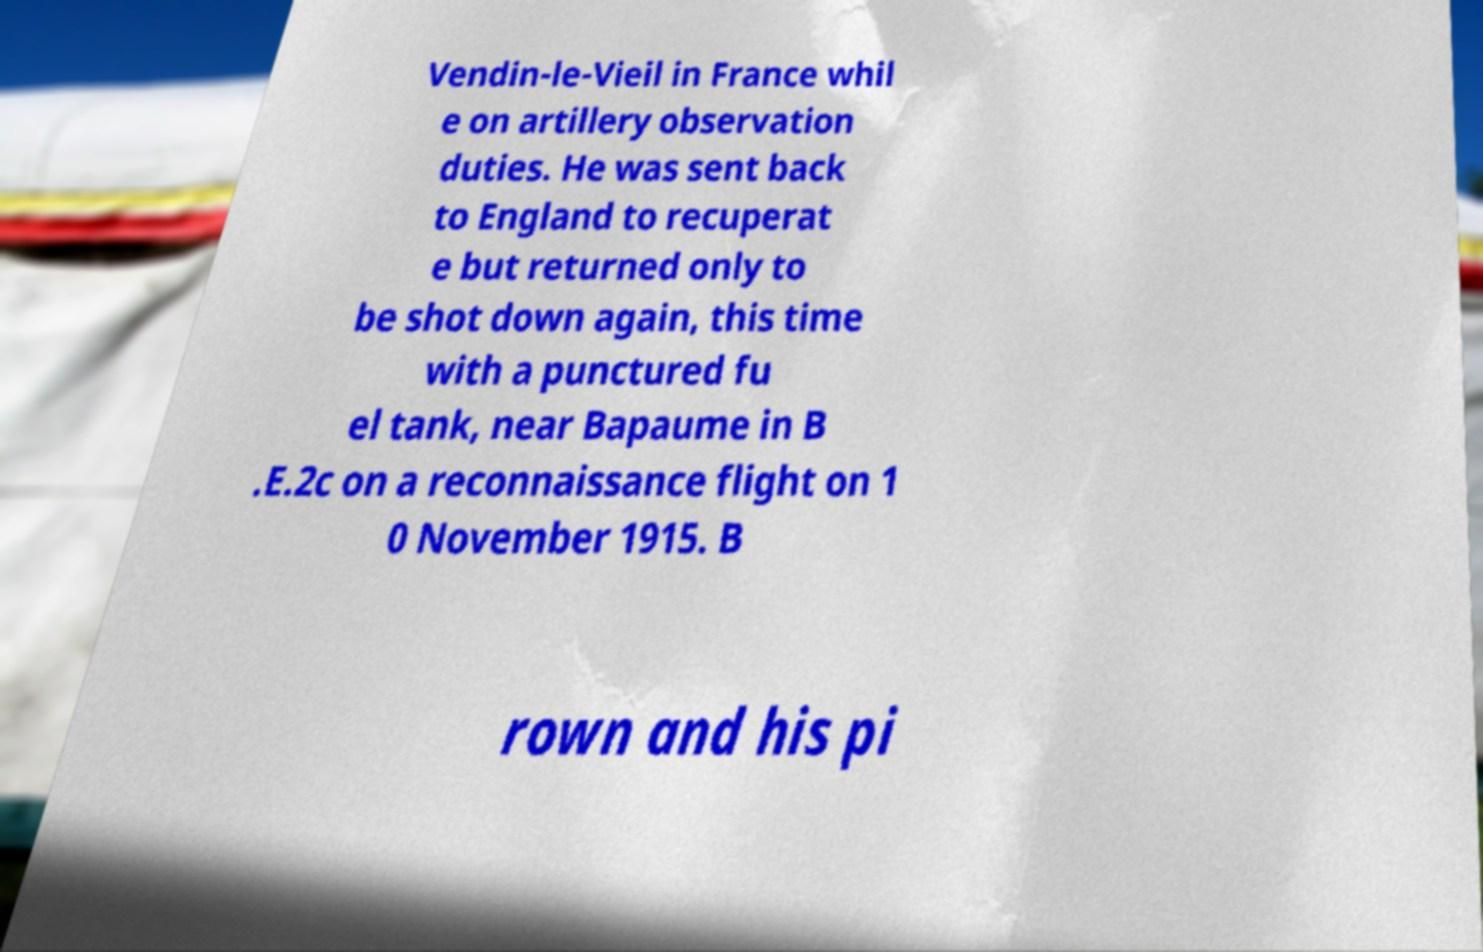Please read and relay the text visible in this image. What does it say? Vendin-le-Vieil in France whil e on artillery observation duties. He was sent back to England to recuperat e but returned only to be shot down again, this time with a punctured fu el tank, near Bapaume in B .E.2c on a reconnaissance flight on 1 0 November 1915. B rown and his pi 